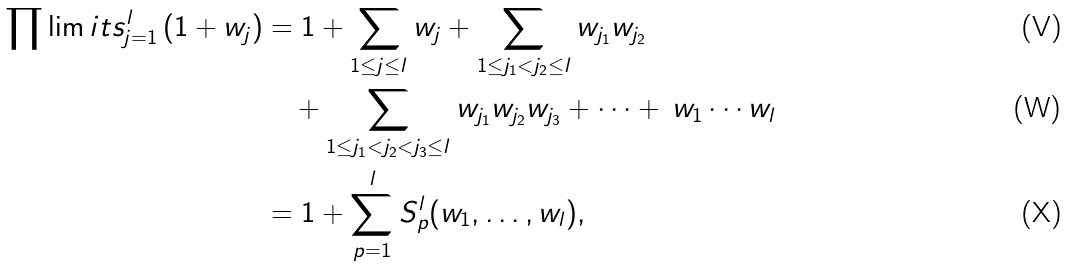<formula> <loc_0><loc_0><loc_500><loc_500>\prod \lim i t s _ { j = 1 } ^ { l } \left ( 1 + w _ { j } \right ) & = 1 + \sum _ { 1 \leq j \leq l } w _ { j } + \sum _ { 1 \leq j _ { 1 } < j _ { 2 } \leq l } w _ { j _ { 1 } } w _ { j _ { 2 } } \\ & \quad + \sum _ { 1 \leq j _ { 1 } < j _ { 2 } < j _ { 3 } \leq l } w _ { j _ { 1 } } w _ { j _ { 2 } } w _ { j _ { 3 } } + \dots + \, w _ { 1 } \cdots w _ { l } \\ & = 1 + \sum _ { p = 1 } ^ { l } S _ { p } ^ { l } ( w _ { 1 } , \dots , w _ { l } ) ,</formula> 